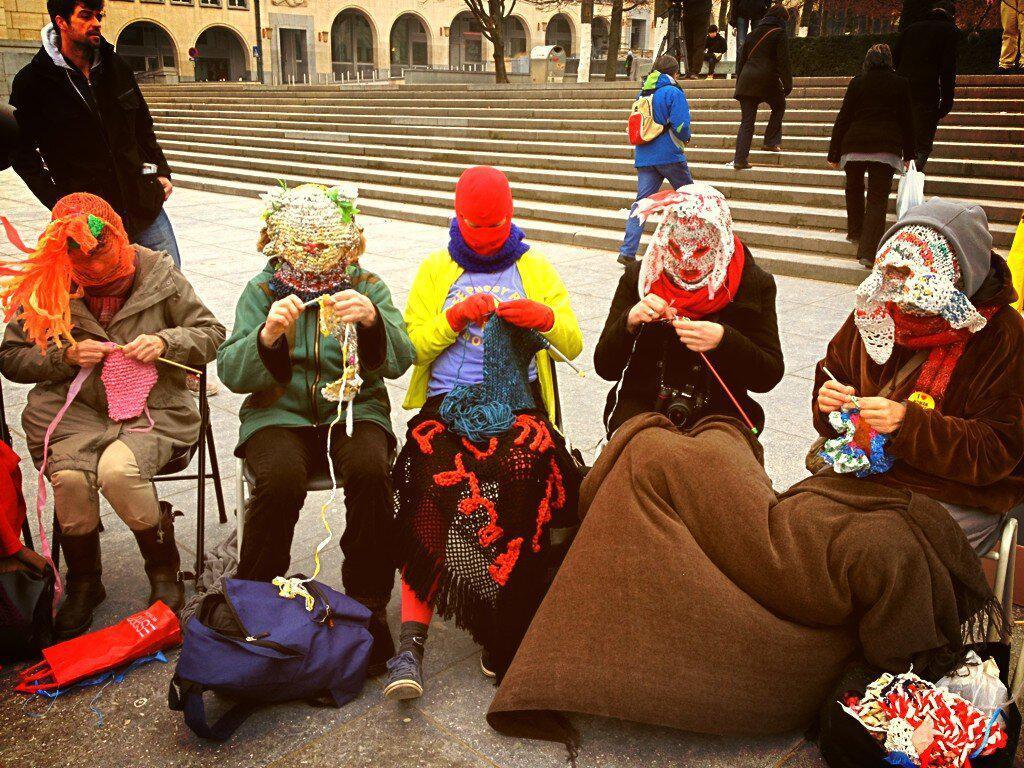How would you summarize this image in a sentence or two? This is an outside view. Here I can see few people wearing masks to their faces, holding some threads in their hands and looking at the threads. At the bottom there are few bags and some other objects placed on the ground. At the back of these people there is a man standing and looking at these people. On the right side few people are climbing the stairs. At the top of the image there are buildings, trees and poles. 